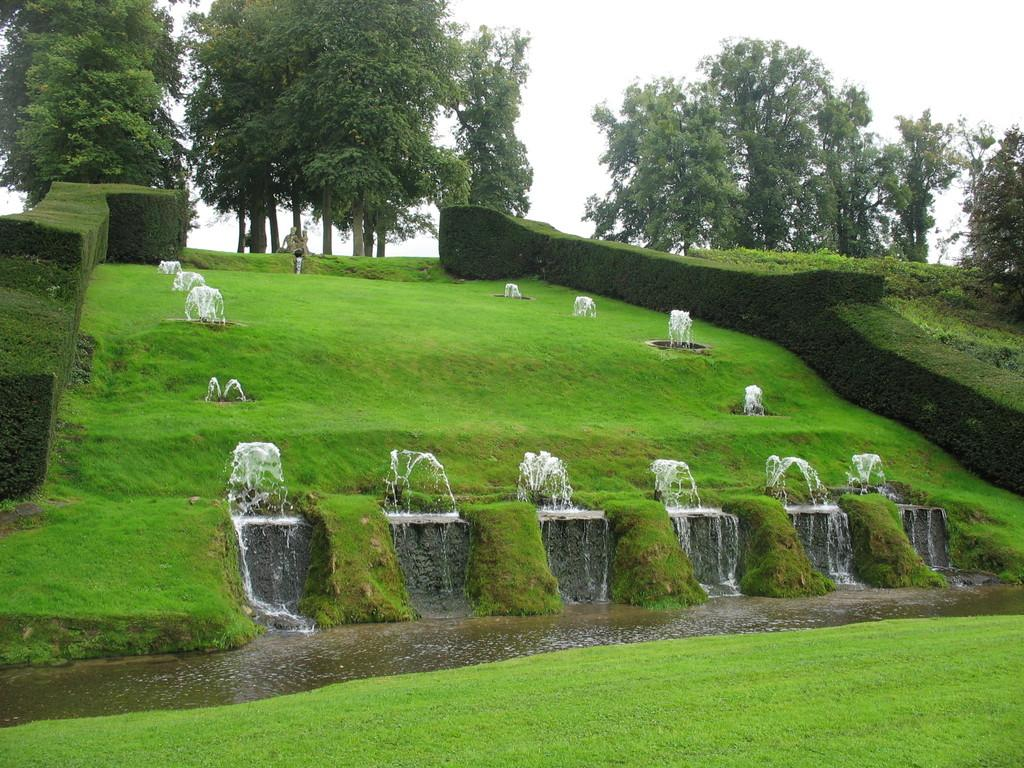What type of natural environment is depicted in the image? The image contains water, grass, shrubs, and trees, which are all elements of a natural environment. Can you describe the vegetation present in the image? There is grass, shrubs, and trees visible in the image. What type of water is present in the image? The image only shows water, without specifying its type. How many streets can be seen in the image? There are no streets present in the image, as it depicts a natural environment with water, grass, shrubs, and trees. 